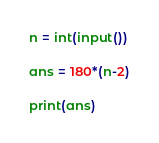Convert code to text. <code><loc_0><loc_0><loc_500><loc_500><_Python_>n = int(input())

ans = 180*(n-2)

print(ans)</code> 